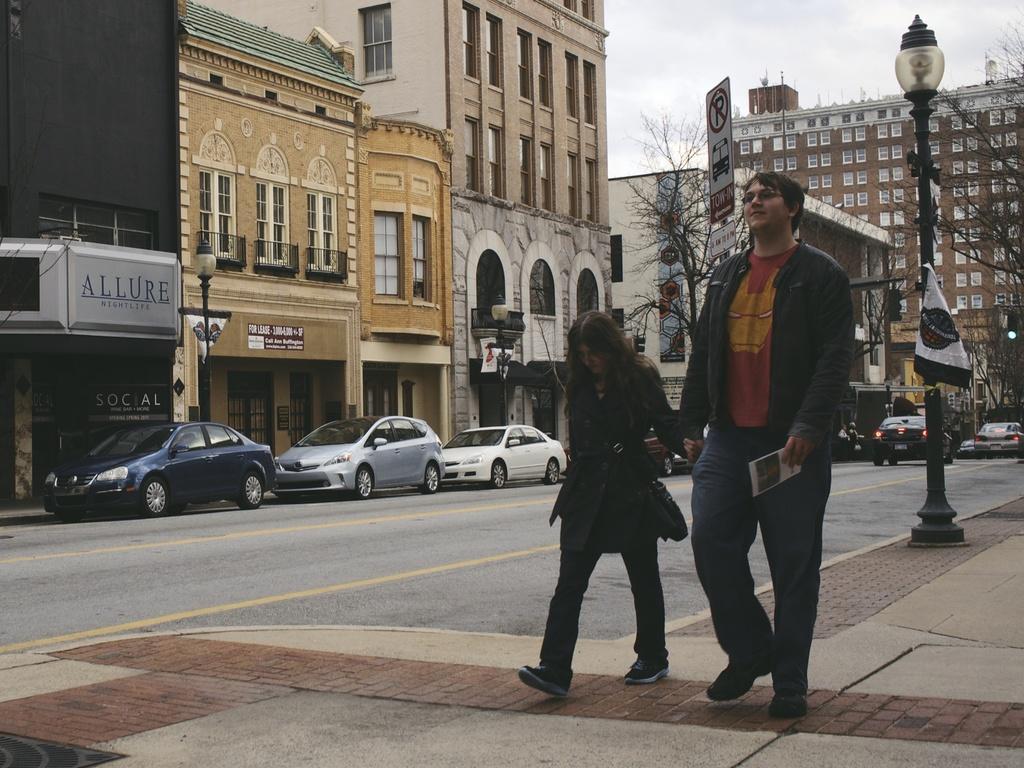Could you give a brief overview of what you see in this image? This is an outside view. Here I can see a man and a woman are walking on the footpath. At the back of the people I can see a street light. In the background there are some cars on the road and also I can see the buildings and trees. On the top of the image I can see the sky. 